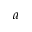<formula> <loc_0><loc_0><loc_500><loc_500>a</formula> 